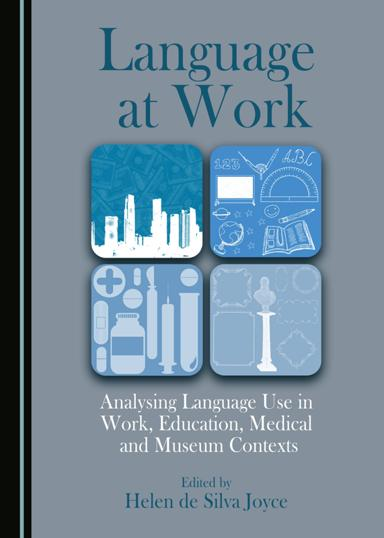Who is the editor of the book? The book, "Language at Work," is edited by Helen de Silva Joyce. She brings her expertise to this compilation, offering readers an in-depth analysis of language use across different contexts such as workplaces, educational institutions, medical environments, and museums. 